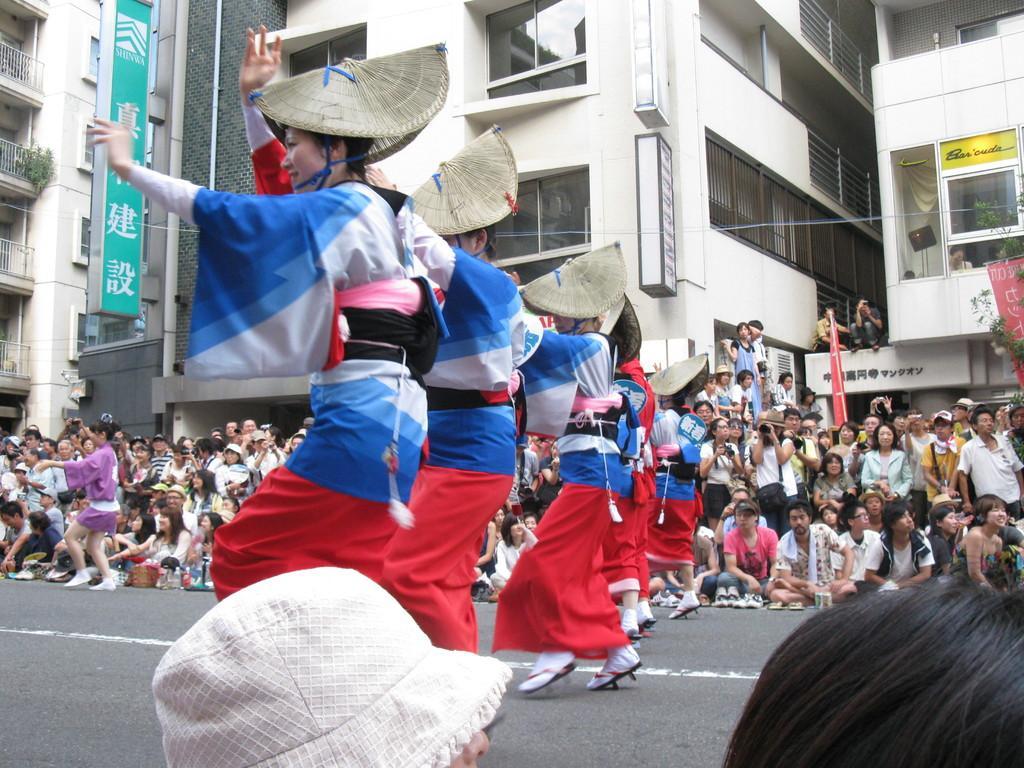Describe this image in one or two sentences. In this picture we can see group of women wearing blue and red color dresses with caps dancing on the road. Behind there is a group of audience enjoying and taking photographs. In the background there are some buildings. 